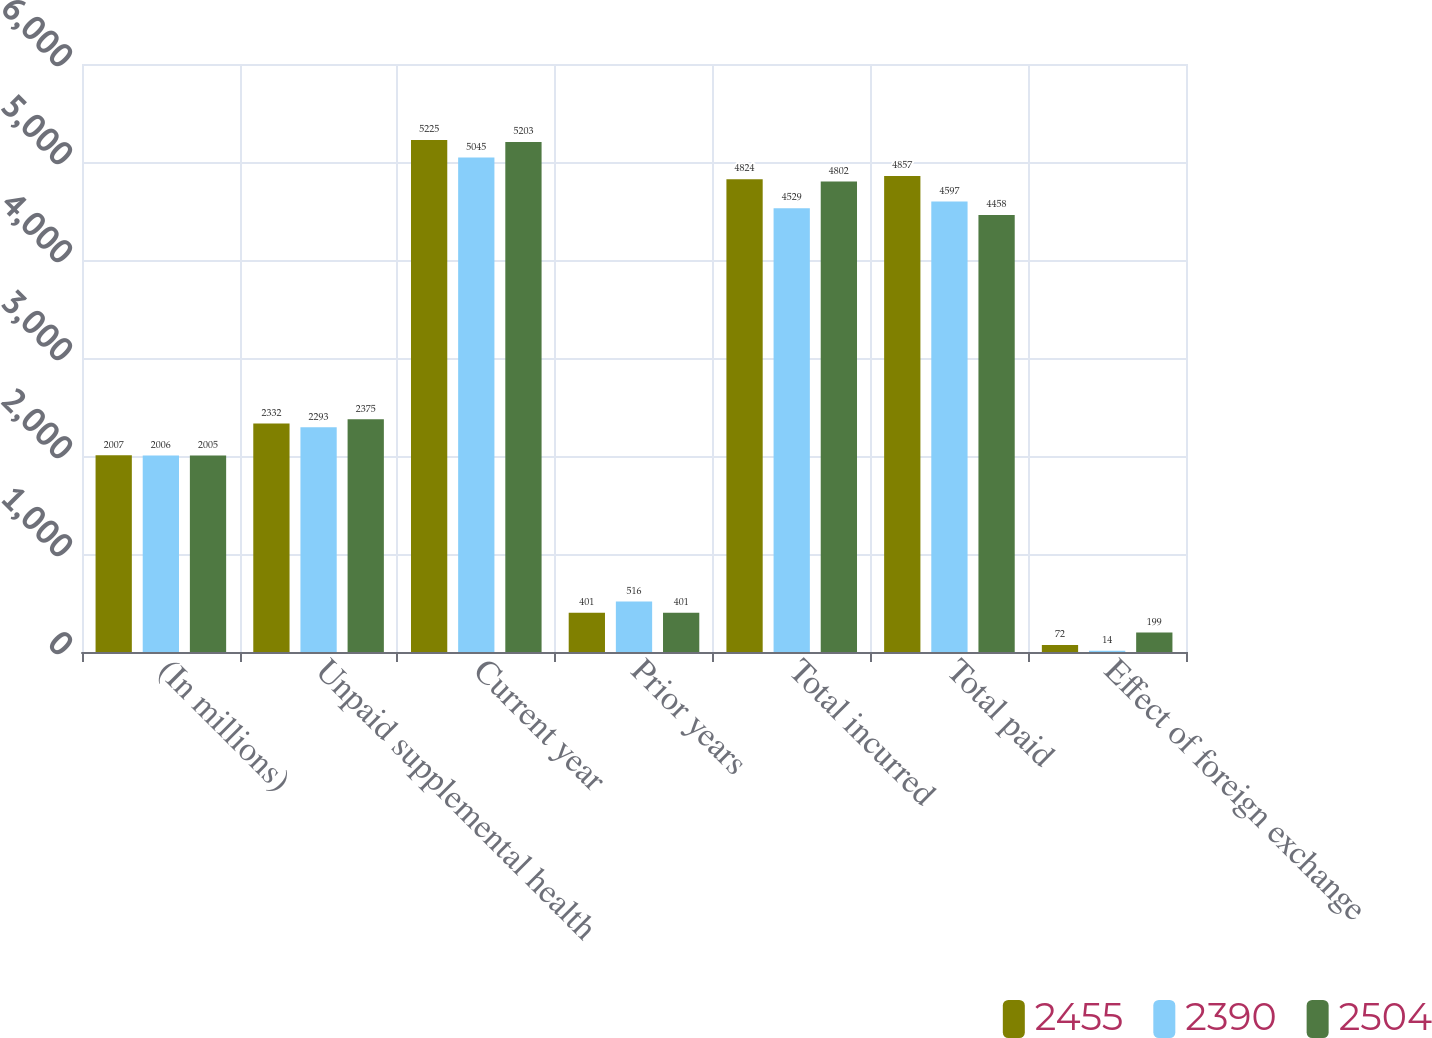Convert chart. <chart><loc_0><loc_0><loc_500><loc_500><stacked_bar_chart><ecel><fcel>(In millions)<fcel>Unpaid supplemental health<fcel>Current year<fcel>Prior years<fcel>Total incurred<fcel>Total paid<fcel>Effect of foreign exchange<nl><fcel>2455<fcel>2007<fcel>2332<fcel>5225<fcel>401<fcel>4824<fcel>4857<fcel>72<nl><fcel>2390<fcel>2006<fcel>2293<fcel>5045<fcel>516<fcel>4529<fcel>4597<fcel>14<nl><fcel>2504<fcel>2005<fcel>2375<fcel>5203<fcel>401<fcel>4802<fcel>4458<fcel>199<nl></chart> 